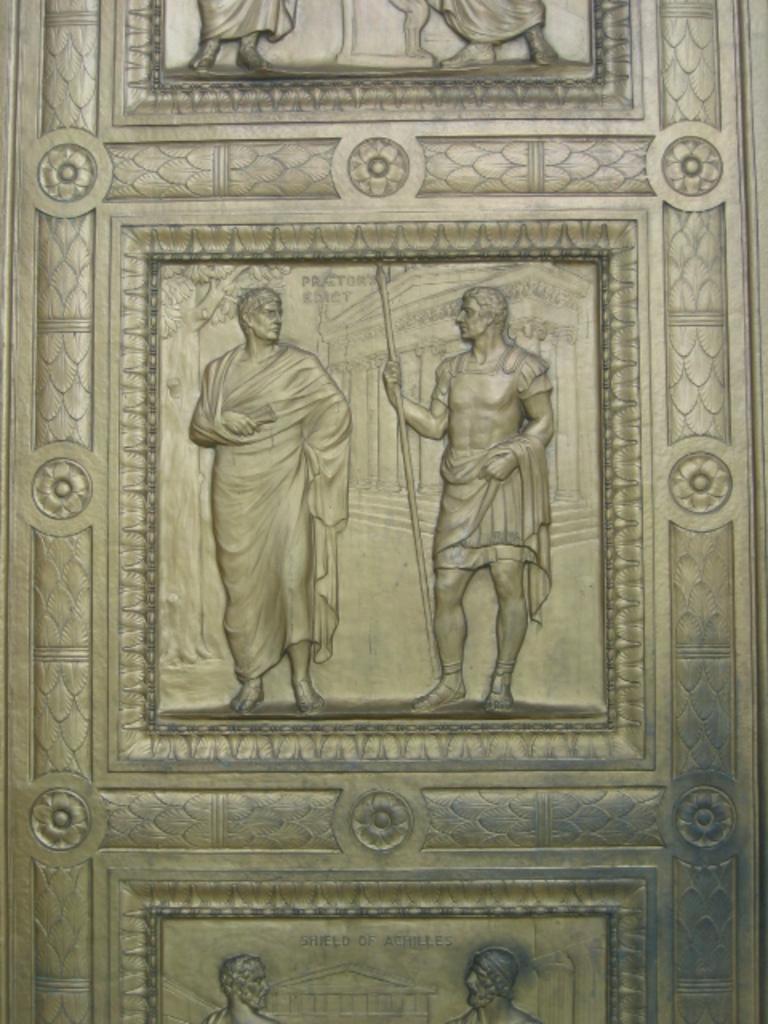In one or two sentences, can you explain what this image depicts? In this image we can see sculptures on the door. 